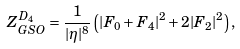<formula> <loc_0><loc_0><loc_500><loc_500>Z _ { G S O } ^ { D _ { 4 } } = \frac { 1 } { | \eta | ^ { 8 } } \left ( | F _ { 0 } + F _ { 4 } | ^ { 2 } + 2 | F _ { 2 } | ^ { 2 } \right ) ,</formula> 